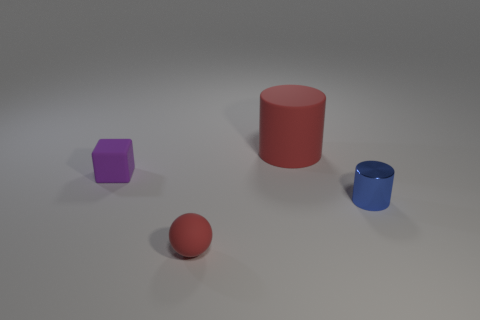Add 2 large blue rubber cubes. How many objects exist? 6 Subtract all blocks. How many objects are left? 3 Subtract all red matte cylinders. Subtract all blue objects. How many objects are left? 2 Add 4 purple rubber things. How many purple rubber things are left? 5 Add 3 big gray metallic things. How many big gray metallic things exist? 3 Subtract 0 gray cylinders. How many objects are left? 4 